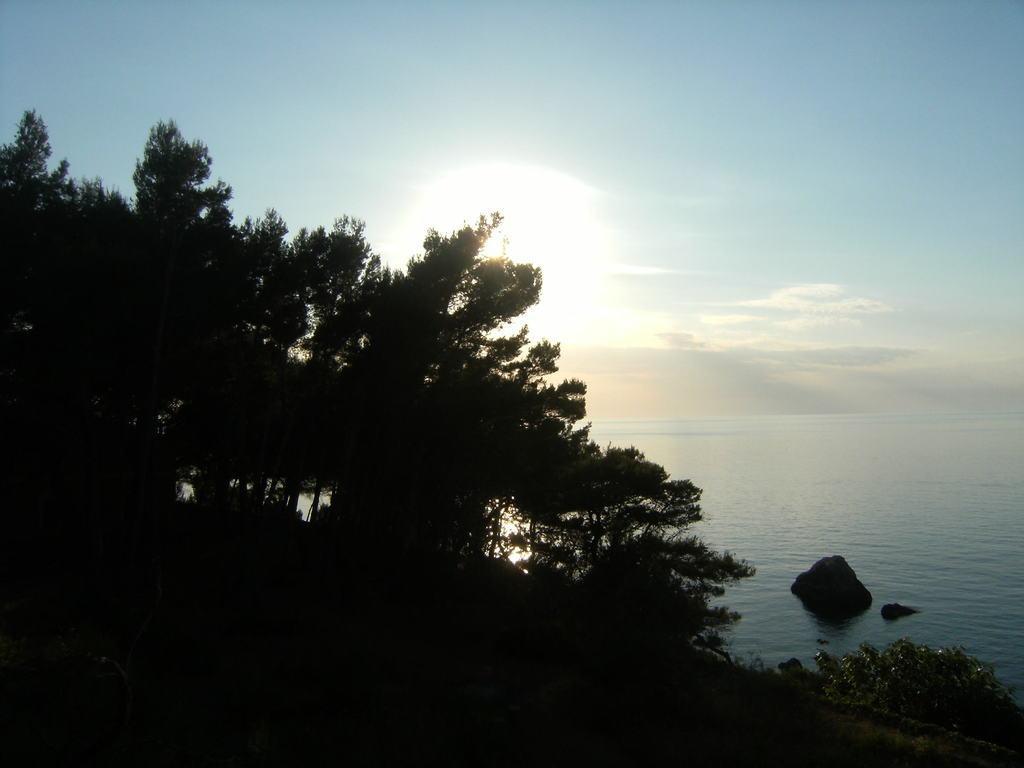Could you give a brief overview of what you see in this image? In this image there are trees, stones in the water, sun rays and some clouds in the sky. 